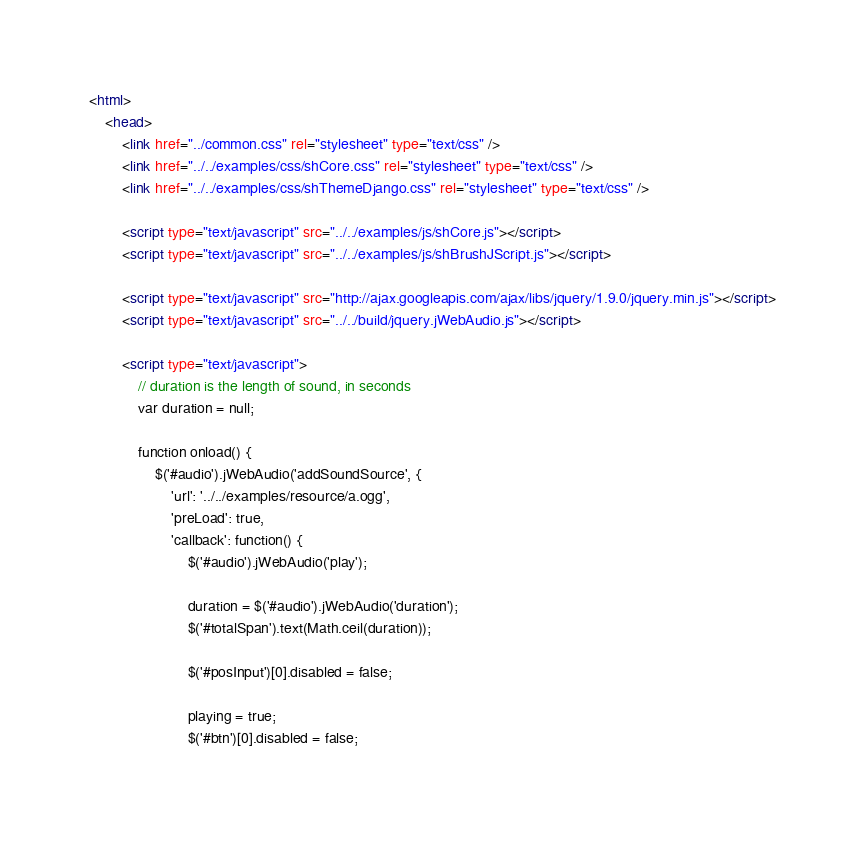<code> <loc_0><loc_0><loc_500><loc_500><_HTML_><html>
    <head>
        <link href="../common.css" rel="stylesheet" type="text/css" />
        <link href="../../examples/css/shCore.css" rel="stylesheet" type="text/css" />
        <link href="../../examples/css/shThemeDjango.css" rel="stylesheet" type="text/css" />
        
        <script type="text/javascript" src="../../examples/js/shCore.js"></script>
        <script type="text/javascript" src="../../examples/js/shBrushJScript.js"></script>
        
        <script type="text/javascript" src="http://ajax.googleapis.com/ajax/libs/jquery/1.9.0/jquery.min.js"></script>
        <script type="text/javascript" src="../../build/jquery.jWebAudio.js"></script>
        
        <script type="text/javascript">
            // duration is the length of sound, in seconds
            var duration = null;
            
            function onload() {
                $('#audio').jWebAudio('addSoundSource', {
                    'url': '../../examples/resource/a.ogg',
                    'preLoad': true,
                    'callback': function() {
                        $('#audio').jWebAudio('play');
                        
                        duration = $('#audio').jWebAudio('duration');
                        $('#totalSpan').text(Math.ceil(duration));
                        
                        $('#posInput')[0].disabled = false;
                        
                        playing = true;
                        $('#btn')[0].disabled = false;
                        </code> 